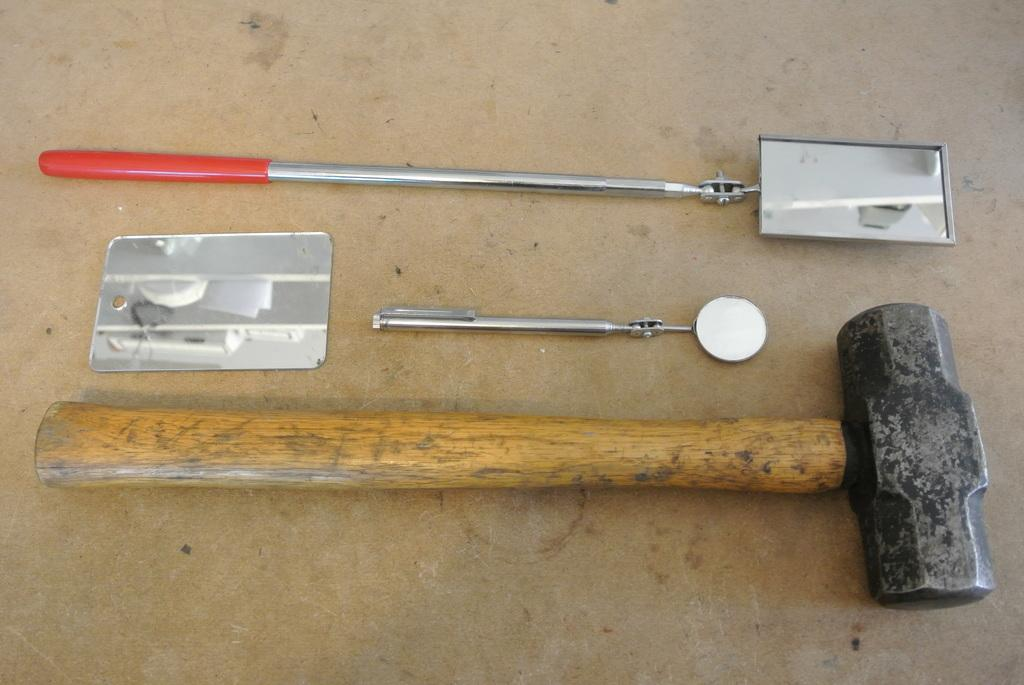What tool is present in the image? There is a hammer in the image. What other object can be seen in the image? There is a stick in the image. How are the stick and mirror related in the image? The mirror is attached to the stick. What is the color of the surface on which the objects are placed? The objects are placed on a brown surface. Who is the owner of the hammer in the image? There is no information about the ownership of the hammer in the image. Can you see a chessboard in the image? There is no chessboard present in the image. 